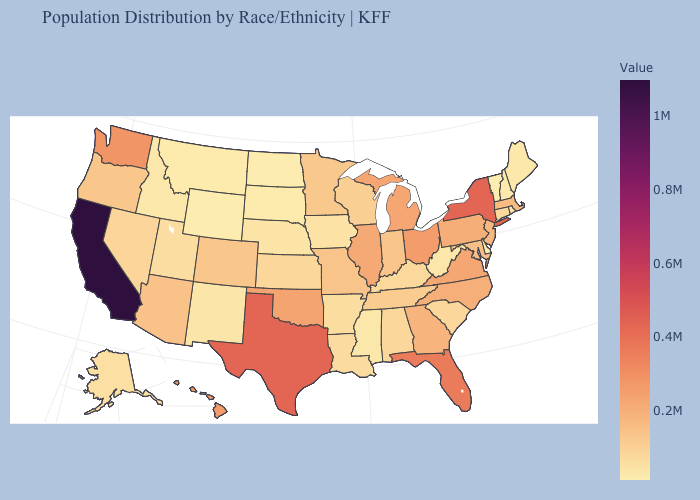Does Vermont have the lowest value in the USA?
Write a very short answer. Yes. Which states have the lowest value in the South?
Concise answer only. Delaware. Is the legend a continuous bar?
Be succinct. Yes. Which states have the lowest value in the USA?
Be succinct. Vermont. Does North Carolina have the highest value in the USA?
Give a very brief answer. No. Does Florida have the lowest value in the USA?
Short answer required. No. Is the legend a continuous bar?
Write a very short answer. Yes. 